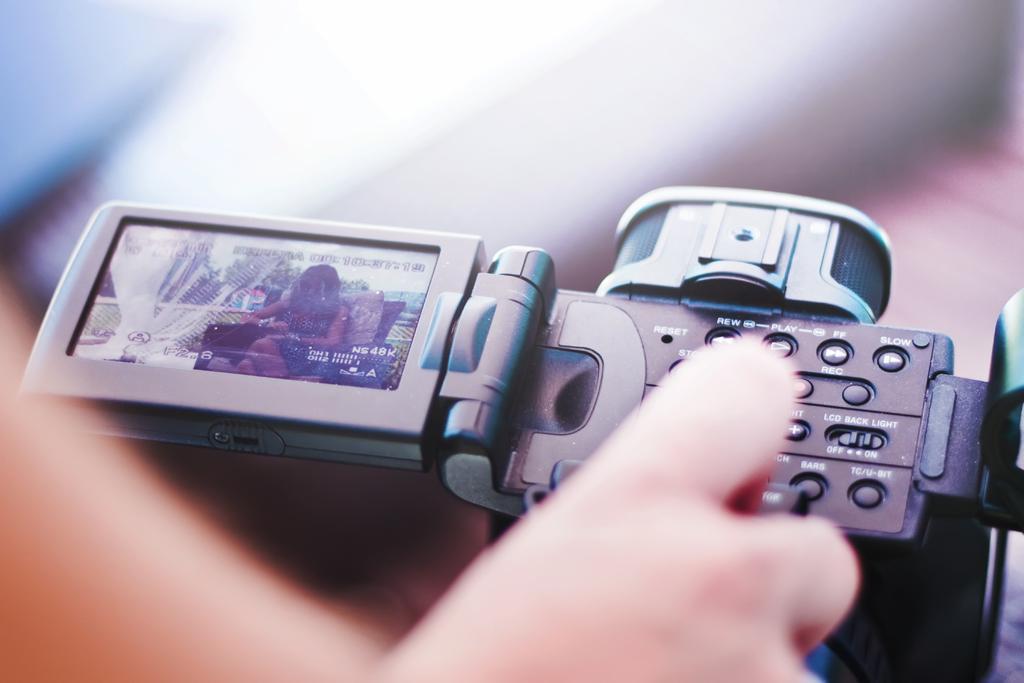Can you describe this image briefly? In this image there is one person's hand as we can see on the bottom of this image and there is a camera in middle of this image. 